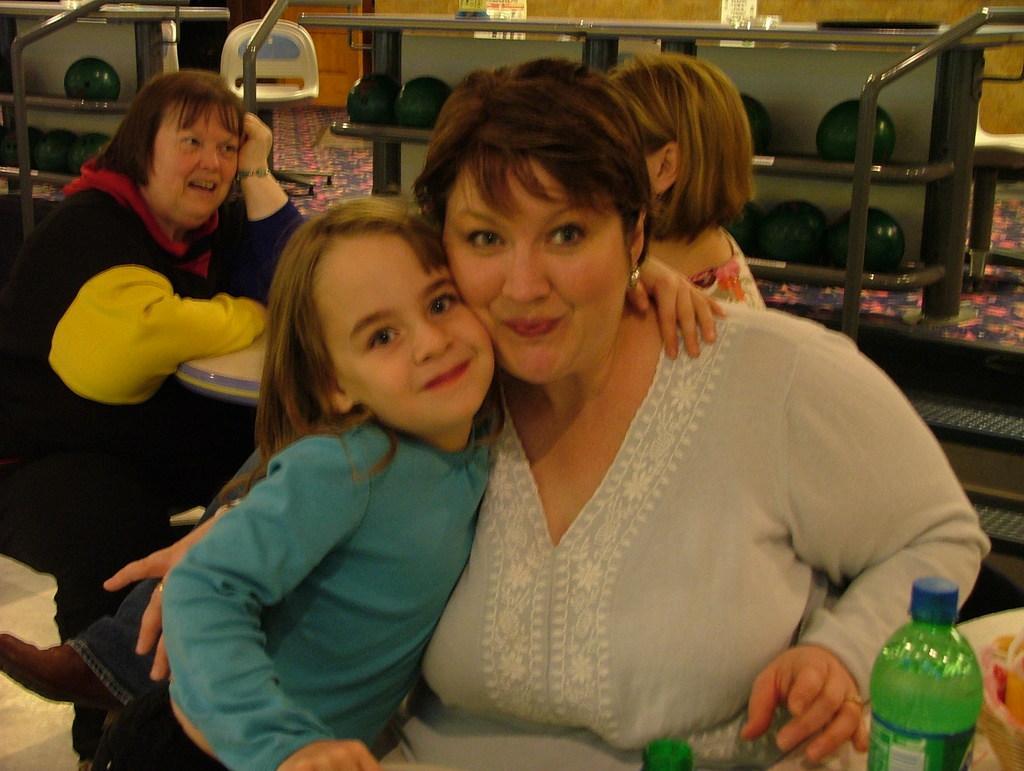Describe this image in one or two sentences. there are 4 people. 2 people are at the front. in front of them there is a green color plastic bottle. behind them 2 people are sitting and talking to each other. at the back there are shelves in which there are green balls. 